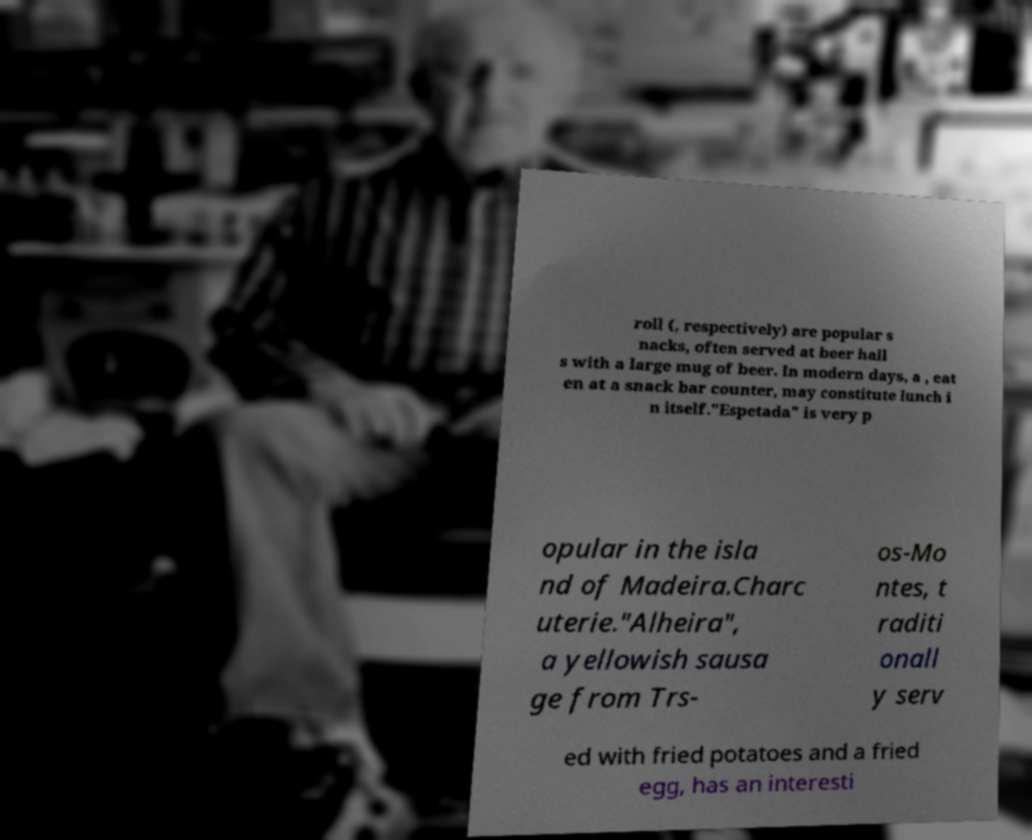There's text embedded in this image that I need extracted. Can you transcribe it verbatim? roll (, respectively) are popular s nacks, often served at beer hall s with a large mug of beer. In modern days, a , eat en at a snack bar counter, may constitute lunch i n itself."Espetada" is very p opular in the isla nd of Madeira.Charc uterie."Alheira", a yellowish sausa ge from Trs- os-Mo ntes, t raditi onall y serv ed with fried potatoes and a fried egg, has an interesti 